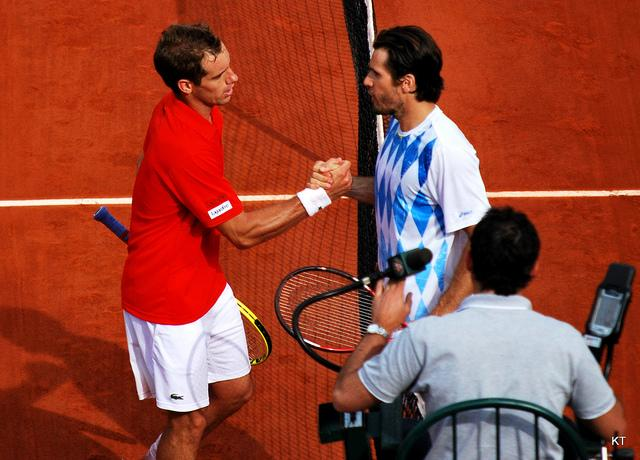What is the man in the chair known as?

Choices:
A) line judge
B) referee
C) adjudicator
D) umpire referee 